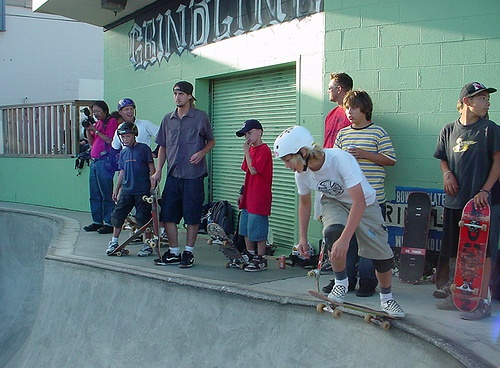Describe the objects in this image and their specific colors. I can see people in teal, black, gray, and maroon tones, people in teal, gray, darkgray, and lightblue tones, people in teal, black, gray, navy, and darkblue tones, people in teal, black, gray, and darkgray tones, and people in teal, maroon, black, brown, and gray tones in this image. 